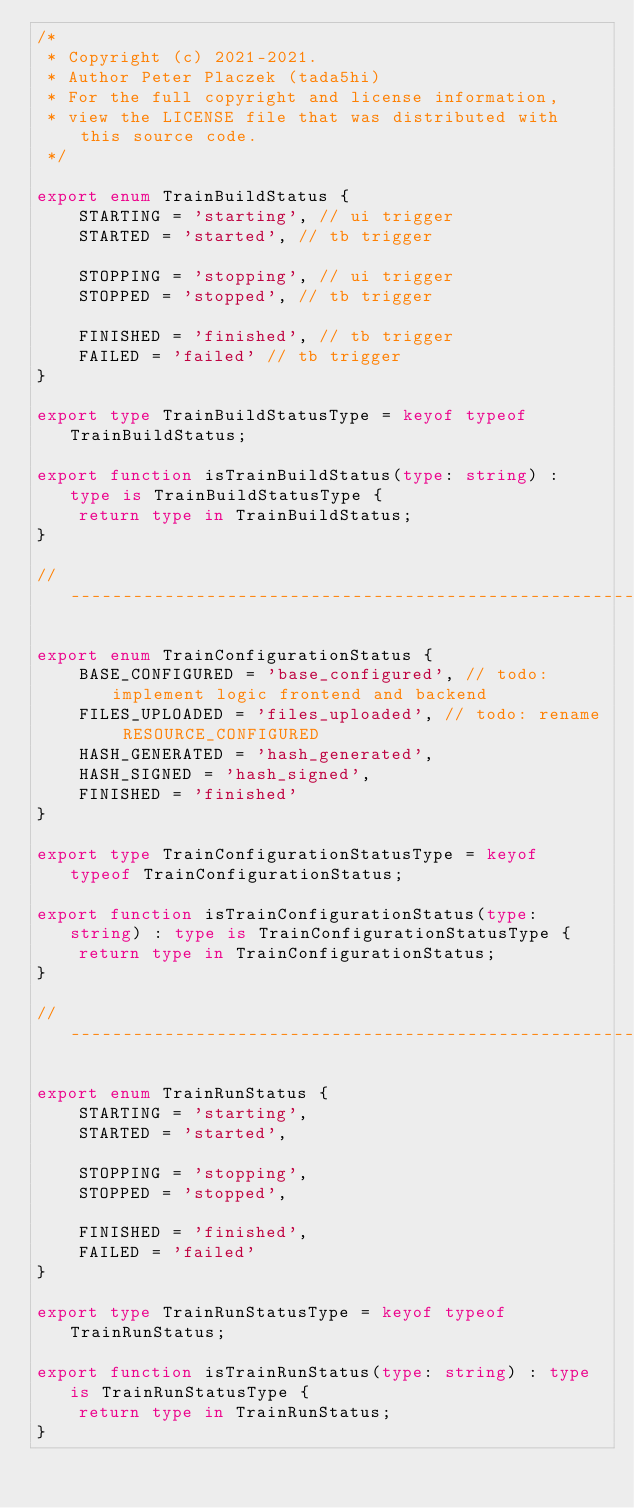Convert code to text. <code><loc_0><loc_0><loc_500><loc_500><_TypeScript_>/*
 * Copyright (c) 2021-2021.
 * Author Peter Placzek (tada5hi)
 * For the full copyright and license information,
 * view the LICENSE file that was distributed with this source code.
 */

export enum TrainBuildStatus {
    STARTING = 'starting', // ui trigger
    STARTED = 'started', // tb trigger

    STOPPING = 'stopping', // ui trigger
    STOPPED = 'stopped', // tb trigger

    FINISHED = 'finished', // tb trigger
    FAILED = 'failed' // tb trigger
}

export type TrainBuildStatusType = keyof typeof TrainBuildStatus;

export function isTrainBuildStatus(type: string) : type is TrainBuildStatusType {
    return type in TrainBuildStatus;
}

// -------------------------------------------------------------------------

export enum TrainConfigurationStatus {
    BASE_CONFIGURED = 'base_configured', // todo: implement logic frontend and backend
    FILES_UPLOADED = 'files_uploaded', // todo: rename RESOURCE_CONFIGURED
    HASH_GENERATED = 'hash_generated',
    HASH_SIGNED = 'hash_signed',
    FINISHED = 'finished'
}

export type TrainConfigurationStatusType = keyof typeof TrainConfigurationStatus;

export function isTrainConfigurationStatus(type: string) : type is TrainConfigurationStatusType {
    return type in TrainConfigurationStatus;
}

// -------------------------------------------------------------------------

export enum TrainRunStatus {
    STARTING = 'starting',
    STARTED = 'started',

    STOPPING = 'stopping',
    STOPPED = 'stopped',

    FINISHED = 'finished',
    FAILED = 'failed'
}

export type TrainRunStatusType = keyof typeof TrainRunStatus;

export function isTrainRunStatus(type: string) : type is TrainRunStatusType {
    return type in TrainRunStatus;
}
</code> 